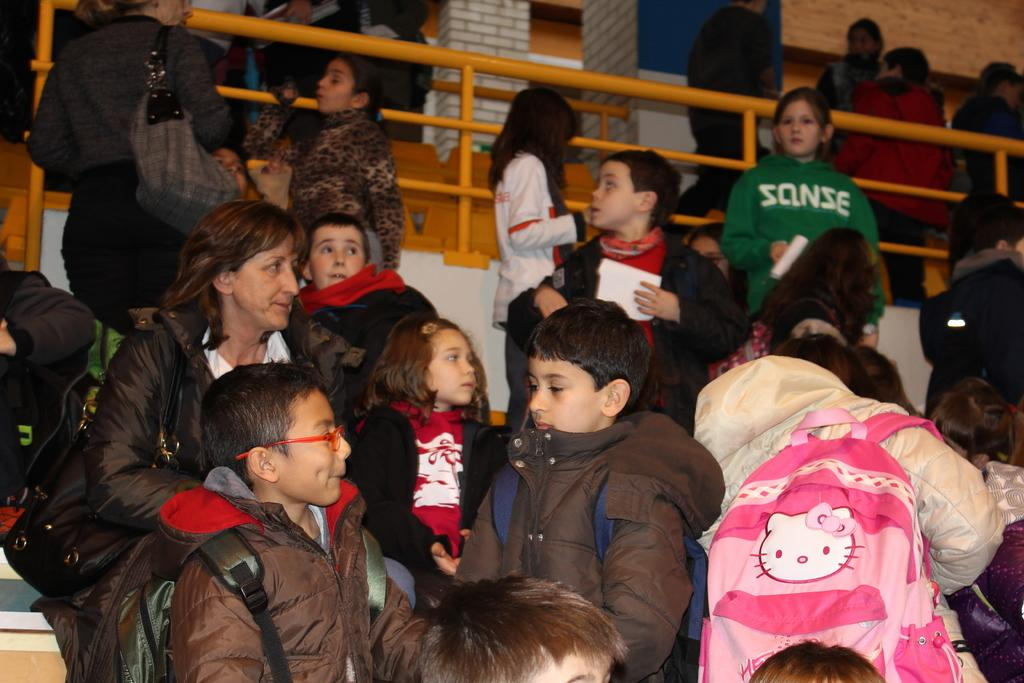How many people are in the image? There is a group of persons in the image, but the exact number cannot be determined from the provided facts. What color is the bag visible in the image? There is a pink color bag in the image. What can be seen in the background of the image? There is a wall, pillars, chairs, and a deck rail in the background of the image. What type of shock can be seen affecting the persons in the image? There is no indication of any shock or electrical disturbance in the image; it simply shows a group of persons and various background elements. 